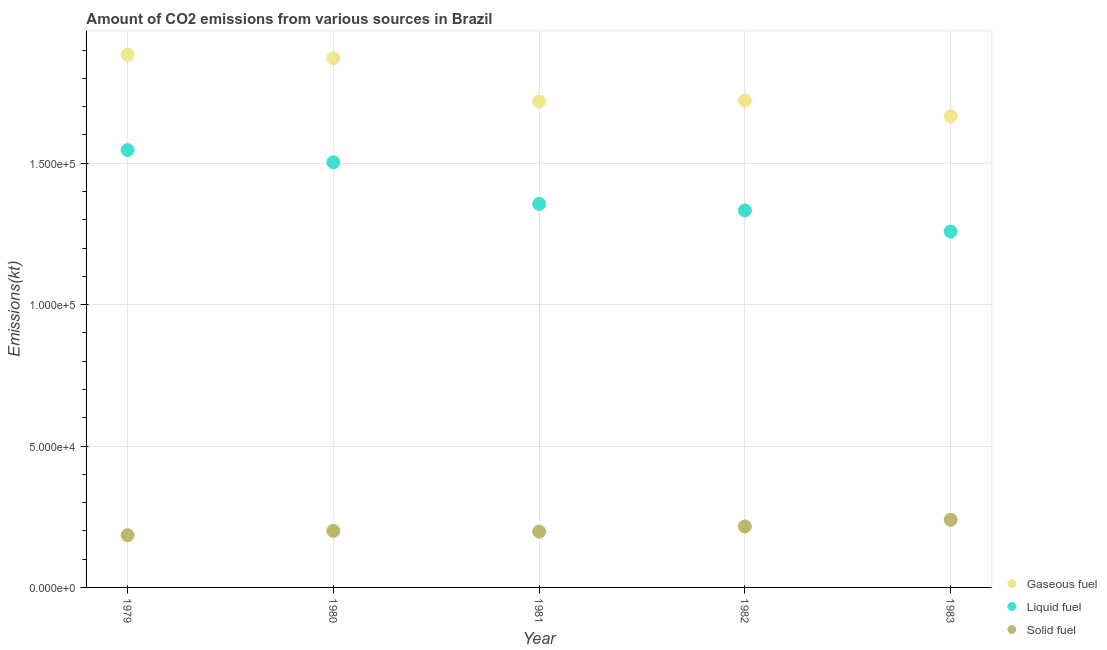What is the amount of co2 emissions from solid fuel in 1982?
Your answer should be compact. 2.16e+04. Across all years, what is the maximum amount of co2 emissions from gaseous fuel?
Ensure brevity in your answer.  1.88e+05. Across all years, what is the minimum amount of co2 emissions from liquid fuel?
Give a very brief answer. 1.26e+05. In which year was the amount of co2 emissions from solid fuel maximum?
Your answer should be compact. 1983. What is the total amount of co2 emissions from liquid fuel in the graph?
Offer a terse response. 7.00e+05. What is the difference between the amount of co2 emissions from gaseous fuel in 1980 and that in 1982?
Ensure brevity in your answer.  1.49e+04. What is the difference between the amount of co2 emissions from solid fuel in 1981 and the amount of co2 emissions from gaseous fuel in 1980?
Make the answer very short. -1.67e+05. What is the average amount of co2 emissions from gaseous fuel per year?
Offer a terse response. 1.77e+05. In the year 1983, what is the difference between the amount of co2 emissions from gaseous fuel and amount of co2 emissions from liquid fuel?
Offer a terse response. 4.08e+04. What is the ratio of the amount of co2 emissions from liquid fuel in 1981 to that in 1982?
Your answer should be very brief. 1.02. What is the difference between the highest and the second highest amount of co2 emissions from gaseous fuel?
Your answer should be compact. 1232.11. What is the difference between the highest and the lowest amount of co2 emissions from liquid fuel?
Keep it short and to the point. 2.88e+04. Is the sum of the amount of co2 emissions from liquid fuel in 1982 and 1983 greater than the maximum amount of co2 emissions from solid fuel across all years?
Ensure brevity in your answer.  Yes. Is it the case that in every year, the sum of the amount of co2 emissions from gaseous fuel and amount of co2 emissions from liquid fuel is greater than the amount of co2 emissions from solid fuel?
Ensure brevity in your answer.  Yes. Does the amount of co2 emissions from gaseous fuel monotonically increase over the years?
Your answer should be very brief. No. Is the amount of co2 emissions from liquid fuel strictly greater than the amount of co2 emissions from solid fuel over the years?
Offer a terse response. Yes. How many dotlines are there?
Ensure brevity in your answer.  3. How many years are there in the graph?
Your answer should be compact. 5. Does the graph contain grids?
Make the answer very short. Yes. Where does the legend appear in the graph?
Your answer should be compact. Bottom right. How many legend labels are there?
Your answer should be very brief. 3. How are the legend labels stacked?
Your answer should be compact. Vertical. What is the title of the graph?
Provide a short and direct response. Amount of CO2 emissions from various sources in Brazil. Does "Coal" appear as one of the legend labels in the graph?
Make the answer very short. No. What is the label or title of the X-axis?
Your answer should be compact. Year. What is the label or title of the Y-axis?
Ensure brevity in your answer.  Emissions(kt). What is the Emissions(kt) in Gaseous fuel in 1979?
Your answer should be very brief. 1.88e+05. What is the Emissions(kt) in Liquid fuel in 1979?
Offer a terse response. 1.55e+05. What is the Emissions(kt) in Solid fuel in 1979?
Your response must be concise. 1.85e+04. What is the Emissions(kt) of Gaseous fuel in 1980?
Ensure brevity in your answer.  1.87e+05. What is the Emissions(kt) in Liquid fuel in 1980?
Provide a short and direct response. 1.50e+05. What is the Emissions(kt) of Solid fuel in 1980?
Your answer should be very brief. 2.00e+04. What is the Emissions(kt) in Gaseous fuel in 1981?
Your answer should be very brief. 1.72e+05. What is the Emissions(kt) in Liquid fuel in 1981?
Provide a short and direct response. 1.36e+05. What is the Emissions(kt) in Solid fuel in 1981?
Offer a terse response. 1.97e+04. What is the Emissions(kt) in Gaseous fuel in 1982?
Ensure brevity in your answer.  1.72e+05. What is the Emissions(kt) of Liquid fuel in 1982?
Your answer should be very brief. 1.33e+05. What is the Emissions(kt) of Solid fuel in 1982?
Provide a succinct answer. 2.16e+04. What is the Emissions(kt) of Gaseous fuel in 1983?
Provide a succinct answer. 1.67e+05. What is the Emissions(kt) in Liquid fuel in 1983?
Your answer should be compact. 1.26e+05. What is the Emissions(kt) of Solid fuel in 1983?
Keep it short and to the point. 2.39e+04. Across all years, what is the maximum Emissions(kt) in Gaseous fuel?
Give a very brief answer. 1.88e+05. Across all years, what is the maximum Emissions(kt) of Liquid fuel?
Offer a very short reply. 1.55e+05. Across all years, what is the maximum Emissions(kt) in Solid fuel?
Give a very brief answer. 2.39e+04. Across all years, what is the minimum Emissions(kt) of Gaseous fuel?
Keep it short and to the point. 1.67e+05. Across all years, what is the minimum Emissions(kt) of Liquid fuel?
Your answer should be compact. 1.26e+05. Across all years, what is the minimum Emissions(kt) of Solid fuel?
Your answer should be very brief. 1.85e+04. What is the total Emissions(kt) of Gaseous fuel in the graph?
Offer a terse response. 8.86e+05. What is the total Emissions(kt) in Liquid fuel in the graph?
Ensure brevity in your answer.  7.00e+05. What is the total Emissions(kt) in Solid fuel in the graph?
Provide a succinct answer. 1.04e+05. What is the difference between the Emissions(kt) of Gaseous fuel in 1979 and that in 1980?
Provide a succinct answer. 1232.11. What is the difference between the Emissions(kt) of Liquid fuel in 1979 and that in 1980?
Keep it short and to the point. 4319.73. What is the difference between the Emissions(kt) of Solid fuel in 1979 and that in 1980?
Offer a terse response. -1525.47. What is the difference between the Emissions(kt) in Gaseous fuel in 1979 and that in 1981?
Offer a very short reply. 1.65e+04. What is the difference between the Emissions(kt) of Liquid fuel in 1979 and that in 1981?
Offer a very short reply. 1.90e+04. What is the difference between the Emissions(kt) of Solid fuel in 1979 and that in 1981?
Offer a terse response. -1261.45. What is the difference between the Emissions(kt) of Gaseous fuel in 1979 and that in 1982?
Offer a terse response. 1.61e+04. What is the difference between the Emissions(kt) of Liquid fuel in 1979 and that in 1982?
Your answer should be compact. 2.14e+04. What is the difference between the Emissions(kt) in Solid fuel in 1979 and that in 1982?
Your answer should be compact. -3091.28. What is the difference between the Emissions(kt) of Gaseous fuel in 1979 and that in 1983?
Offer a very short reply. 2.17e+04. What is the difference between the Emissions(kt) in Liquid fuel in 1979 and that in 1983?
Ensure brevity in your answer.  2.88e+04. What is the difference between the Emissions(kt) of Solid fuel in 1979 and that in 1983?
Provide a short and direct response. -5467.5. What is the difference between the Emissions(kt) in Gaseous fuel in 1980 and that in 1981?
Give a very brief answer. 1.53e+04. What is the difference between the Emissions(kt) of Liquid fuel in 1980 and that in 1981?
Ensure brevity in your answer.  1.47e+04. What is the difference between the Emissions(kt) of Solid fuel in 1980 and that in 1981?
Make the answer very short. 264.02. What is the difference between the Emissions(kt) in Gaseous fuel in 1980 and that in 1982?
Offer a terse response. 1.49e+04. What is the difference between the Emissions(kt) of Liquid fuel in 1980 and that in 1982?
Offer a terse response. 1.70e+04. What is the difference between the Emissions(kt) in Solid fuel in 1980 and that in 1982?
Make the answer very short. -1565.81. What is the difference between the Emissions(kt) of Gaseous fuel in 1980 and that in 1983?
Ensure brevity in your answer.  2.05e+04. What is the difference between the Emissions(kt) of Liquid fuel in 1980 and that in 1983?
Ensure brevity in your answer.  2.45e+04. What is the difference between the Emissions(kt) of Solid fuel in 1980 and that in 1983?
Offer a terse response. -3942.03. What is the difference between the Emissions(kt) in Gaseous fuel in 1981 and that in 1982?
Keep it short and to the point. -370.37. What is the difference between the Emissions(kt) of Liquid fuel in 1981 and that in 1982?
Offer a terse response. 2335.88. What is the difference between the Emissions(kt) of Solid fuel in 1981 and that in 1982?
Your answer should be very brief. -1829.83. What is the difference between the Emissions(kt) in Gaseous fuel in 1981 and that in 1983?
Provide a succinct answer. 5174.14. What is the difference between the Emissions(kt) of Liquid fuel in 1981 and that in 1983?
Your response must be concise. 9798.22. What is the difference between the Emissions(kt) of Solid fuel in 1981 and that in 1983?
Keep it short and to the point. -4206.05. What is the difference between the Emissions(kt) of Gaseous fuel in 1982 and that in 1983?
Make the answer very short. 5544.5. What is the difference between the Emissions(kt) of Liquid fuel in 1982 and that in 1983?
Offer a terse response. 7462.35. What is the difference between the Emissions(kt) of Solid fuel in 1982 and that in 1983?
Offer a terse response. -2376.22. What is the difference between the Emissions(kt) in Gaseous fuel in 1979 and the Emissions(kt) in Liquid fuel in 1980?
Offer a terse response. 3.80e+04. What is the difference between the Emissions(kt) of Gaseous fuel in 1979 and the Emissions(kt) of Solid fuel in 1980?
Provide a succinct answer. 1.68e+05. What is the difference between the Emissions(kt) of Liquid fuel in 1979 and the Emissions(kt) of Solid fuel in 1980?
Your answer should be compact. 1.35e+05. What is the difference between the Emissions(kt) in Gaseous fuel in 1979 and the Emissions(kt) in Liquid fuel in 1981?
Your answer should be very brief. 5.27e+04. What is the difference between the Emissions(kt) of Gaseous fuel in 1979 and the Emissions(kt) of Solid fuel in 1981?
Make the answer very short. 1.69e+05. What is the difference between the Emissions(kt) of Liquid fuel in 1979 and the Emissions(kt) of Solid fuel in 1981?
Ensure brevity in your answer.  1.35e+05. What is the difference between the Emissions(kt) of Gaseous fuel in 1979 and the Emissions(kt) of Liquid fuel in 1982?
Offer a very short reply. 5.50e+04. What is the difference between the Emissions(kt) in Gaseous fuel in 1979 and the Emissions(kt) in Solid fuel in 1982?
Keep it short and to the point. 1.67e+05. What is the difference between the Emissions(kt) of Liquid fuel in 1979 and the Emissions(kt) of Solid fuel in 1982?
Give a very brief answer. 1.33e+05. What is the difference between the Emissions(kt) in Gaseous fuel in 1979 and the Emissions(kt) in Liquid fuel in 1983?
Your response must be concise. 6.25e+04. What is the difference between the Emissions(kt) of Gaseous fuel in 1979 and the Emissions(kt) of Solid fuel in 1983?
Give a very brief answer. 1.64e+05. What is the difference between the Emissions(kt) in Liquid fuel in 1979 and the Emissions(kt) in Solid fuel in 1983?
Keep it short and to the point. 1.31e+05. What is the difference between the Emissions(kt) in Gaseous fuel in 1980 and the Emissions(kt) in Liquid fuel in 1981?
Your answer should be very brief. 5.15e+04. What is the difference between the Emissions(kt) of Gaseous fuel in 1980 and the Emissions(kt) of Solid fuel in 1981?
Your answer should be very brief. 1.67e+05. What is the difference between the Emissions(kt) in Liquid fuel in 1980 and the Emissions(kt) in Solid fuel in 1981?
Your response must be concise. 1.31e+05. What is the difference between the Emissions(kt) of Gaseous fuel in 1980 and the Emissions(kt) of Liquid fuel in 1982?
Offer a terse response. 5.38e+04. What is the difference between the Emissions(kt) in Gaseous fuel in 1980 and the Emissions(kt) in Solid fuel in 1982?
Offer a very short reply. 1.66e+05. What is the difference between the Emissions(kt) in Liquid fuel in 1980 and the Emissions(kt) in Solid fuel in 1982?
Give a very brief answer. 1.29e+05. What is the difference between the Emissions(kt) of Gaseous fuel in 1980 and the Emissions(kt) of Liquid fuel in 1983?
Ensure brevity in your answer.  6.12e+04. What is the difference between the Emissions(kt) of Gaseous fuel in 1980 and the Emissions(kt) of Solid fuel in 1983?
Make the answer very short. 1.63e+05. What is the difference between the Emissions(kt) of Liquid fuel in 1980 and the Emissions(kt) of Solid fuel in 1983?
Make the answer very short. 1.26e+05. What is the difference between the Emissions(kt) of Gaseous fuel in 1981 and the Emissions(kt) of Liquid fuel in 1982?
Give a very brief answer. 3.85e+04. What is the difference between the Emissions(kt) in Gaseous fuel in 1981 and the Emissions(kt) in Solid fuel in 1982?
Your response must be concise. 1.50e+05. What is the difference between the Emissions(kt) in Liquid fuel in 1981 and the Emissions(kt) in Solid fuel in 1982?
Offer a terse response. 1.14e+05. What is the difference between the Emissions(kt) of Gaseous fuel in 1981 and the Emissions(kt) of Liquid fuel in 1983?
Offer a very short reply. 4.60e+04. What is the difference between the Emissions(kt) of Gaseous fuel in 1981 and the Emissions(kt) of Solid fuel in 1983?
Provide a succinct answer. 1.48e+05. What is the difference between the Emissions(kt) in Liquid fuel in 1981 and the Emissions(kt) in Solid fuel in 1983?
Provide a short and direct response. 1.12e+05. What is the difference between the Emissions(kt) of Gaseous fuel in 1982 and the Emissions(kt) of Liquid fuel in 1983?
Offer a very short reply. 4.63e+04. What is the difference between the Emissions(kt) of Gaseous fuel in 1982 and the Emissions(kt) of Solid fuel in 1983?
Provide a succinct answer. 1.48e+05. What is the difference between the Emissions(kt) in Liquid fuel in 1982 and the Emissions(kt) in Solid fuel in 1983?
Ensure brevity in your answer.  1.09e+05. What is the average Emissions(kt) of Gaseous fuel per year?
Offer a terse response. 1.77e+05. What is the average Emissions(kt) in Liquid fuel per year?
Your answer should be very brief. 1.40e+05. What is the average Emissions(kt) in Solid fuel per year?
Offer a very short reply. 2.07e+04. In the year 1979, what is the difference between the Emissions(kt) in Gaseous fuel and Emissions(kt) in Liquid fuel?
Your answer should be compact. 3.37e+04. In the year 1979, what is the difference between the Emissions(kt) of Gaseous fuel and Emissions(kt) of Solid fuel?
Your answer should be compact. 1.70e+05. In the year 1979, what is the difference between the Emissions(kt) of Liquid fuel and Emissions(kt) of Solid fuel?
Make the answer very short. 1.36e+05. In the year 1980, what is the difference between the Emissions(kt) of Gaseous fuel and Emissions(kt) of Liquid fuel?
Offer a terse response. 3.68e+04. In the year 1980, what is the difference between the Emissions(kt) in Gaseous fuel and Emissions(kt) in Solid fuel?
Provide a short and direct response. 1.67e+05. In the year 1980, what is the difference between the Emissions(kt) in Liquid fuel and Emissions(kt) in Solid fuel?
Your answer should be compact. 1.30e+05. In the year 1981, what is the difference between the Emissions(kt) in Gaseous fuel and Emissions(kt) in Liquid fuel?
Offer a very short reply. 3.62e+04. In the year 1981, what is the difference between the Emissions(kt) in Gaseous fuel and Emissions(kt) in Solid fuel?
Offer a very short reply. 1.52e+05. In the year 1981, what is the difference between the Emissions(kt) of Liquid fuel and Emissions(kt) of Solid fuel?
Your answer should be compact. 1.16e+05. In the year 1982, what is the difference between the Emissions(kt) of Gaseous fuel and Emissions(kt) of Liquid fuel?
Your answer should be very brief. 3.89e+04. In the year 1982, what is the difference between the Emissions(kt) of Gaseous fuel and Emissions(kt) of Solid fuel?
Ensure brevity in your answer.  1.51e+05. In the year 1982, what is the difference between the Emissions(kt) of Liquid fuel and Emissions(kt) of Solid fuel?
Your response must be concise. 1.12e+05. In the year 1983, what is the difference between the Emissions(kt) in Gaseous fuel and Emissions(kt) in Liquid fuel?
Provide a succinct answer. 4.08e+04. In the year 1983, what is the difference between the Emissions(kt) of Gaseous fuel and Emissions(kt) of Solid fuel?
Your answer should be compact. 1.43e+05. In the year 1983, what is the difference between the Emissions(kt) in Liquid fuel and Emissions(kt) in Solid fuel?
Provide a succinct answer. 1.02e+05. What is the ratio of the Emissions(kt) in Gaseous fuel in 1979 to that in 1980?
Your answer should be very brief. 1.01. What is the ratio of the Emissions(kt) in Liquid fuel in 1979 to that in 1980?
Provide a short and direct response. 1.03. What is the ratio of the Emissions(kt) in Solid fuel in 1979 to that in 1980?
Offer a terse response. 0.92. What is the ratio of the Emissions(kt) of Gaseous fuel in 1979 to that in 1981?
Provide a short and direct response. 1.1. What is the ratio of the Emissions(kt) of Liquid fuel in 1979 to that in 1981?
Your answer should be compact. 1.14. What is the ratio of the Emissions(kt) in Solid fuel in 1979 to that in 1981?
Your answer should be compact. 0.94. What is the ratio of the Emissions(kt) in Gaseous fuel in 1979 to that in 1982?
Offer a terse response. 1.09. What is the ratio of the Emissions(kt) in Liquid fuel in 1979 to that in 1982?
Your response must be concise. 1.16. What is the ratio of the Emissions(kt) of Solid fuel in 1979 to that in 1982?
Keep it short and to the point. 0.86. What is the ratio of the Emissions(kt) in Gaseous fuel in 1979 to that in 1983?
Make the answer very short. 1.13. What is the ratio of the Emissions(kt) in Liquid fuel in 1979 to that in 1983?
Offer a very short reply. 1.23. What is the ratio of the Emissions(kt) in Solid fuel in 1979 to that in 1983?
Offer a very short reply. 0.77. What is the ratio of the Emissions(kt) in Gaseous fuel in 1980 to that in 1981?
Your answer should be compact. 1.09. What is the ratio of the Emissions(kt) in Liquid fuel in 1980 to that in 1981?
Ensure brevity in your answer.  1.11. What is the ratio of the Emissions(kt) in Solid fuel in 1980 to that in 1981?
Keep it short and to the point. 1.01. What is the ratio of the Emissions(kt) in Gaseous fuel in 1980 to that in 1982?
Make the answer very short. 1.09. What is the ratio of the Emissions(kt) of Liquid fuel in 1980 to that in 1982?
Provide a short and direct response. 1.13. What is the ratio of the Emissions(kt) of Solid fuel in 1980 to that in 1982?
Give a very brief answer. 0.93. What is the ratio of the Emissions(kt) in Gaseous fuel in 1980 to that in 1983?
Make the answer very short. 1.12. What is the ratio of the Emissions(kt) of Liquid fuel in 1980 to that in 1983?
Ensure brevity in your answer.  1.19. What is the ratio of the Emissions(kt) in Solid fuel in 1980 to that in 1983?
Offer a terse response. 0.84. What is the ratio of the Emissions(kt) in Gaseous fuel in 1981 to that in 1982?
Offer a very short reply. 1. What is the ratio of the Emissions(kt) of Liquid fuel in 1981 to that in 1982?
Your answer should be very brief. 1.02. What is the ratio of the Emissions(kt) in Solid fuel in 1981 to that in 1982?
Give a very brief answer. 0.92. What is the ratio of the Emissions(kt) in Gaseous fuel in 1981 to that in 1983?
Make the answer very short. 1.03. What is the ratio of the Emissions(kt) in Liquid fuel in 1981 to that in 1983?
Your answer should be very brief. 1.08. What is the ratio of the Emissions(kt) in Solid fuel in 1981 to that in 1983?
Your answer should be compact. 0.82. What is the ratio of the Emissions(kt) in Gaseous fuel in 1982 to that in 1983?
Your response must be concise. 1.03. What is the ratio of the Emissions(kt) in Liquid fuel in 1982 to that in 1983?
Your answer should be compact. 1.06. What is the ratio of the Emissions(kt) in Solid fuel in 1982 to that in 1983?
Offer a very short reply. 0.9. What is the difference between the highest and the second highest Emissions(kt) in Gaseous fuel?
Your answer should be very brief. 1232.11. What is the difference between the highest and the second highest Emissions(kt) of Liquid fuel?
Offer a terse response. 4319.73. What is the difference between the highest and the second highest Emissions(kt) in Solid fuel?
Your answer should be compact. 2376.22. What is the difference between the highest and the lowest Emissions(kt) of Gaseous fuel?
Your answer should be compact. 2.17e+04. What is the difference between the highest and the lowest Emissions(kt) in Liquid fuel?
Make the answer very short. 2.88e+04. What is the difference between the highest and the lowest Emissions(kt) in Solid fuel?
Your answer should be compact. 5467.5. 